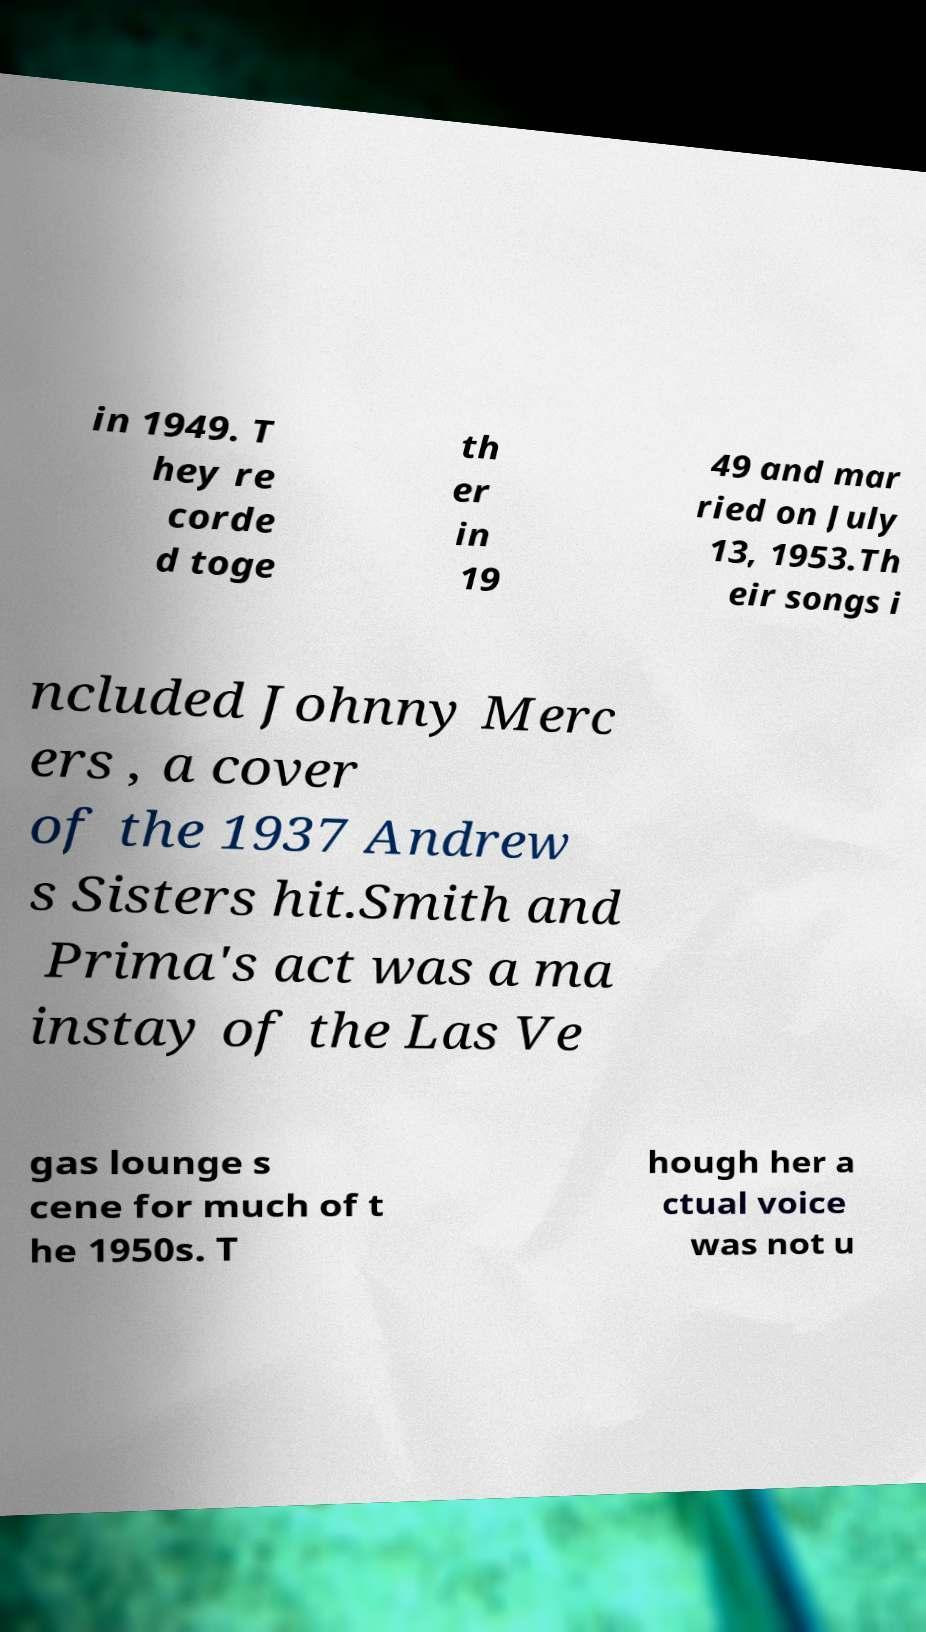For documentation purposes, I need the text within this image transcribed. Could you provide that? in 1949. T hey re corde d toge th er in 19 49 and mar ried on July 13, 1953.Th eir songs i ncluded Johnny Merc ers , a cover of the 1937 Andrew s Sisters hit.Smith and Prima's act was a ma instay of the Las Ve gas lounge s cene for much of t he 1950s. T hough her a ctual voice was not u 